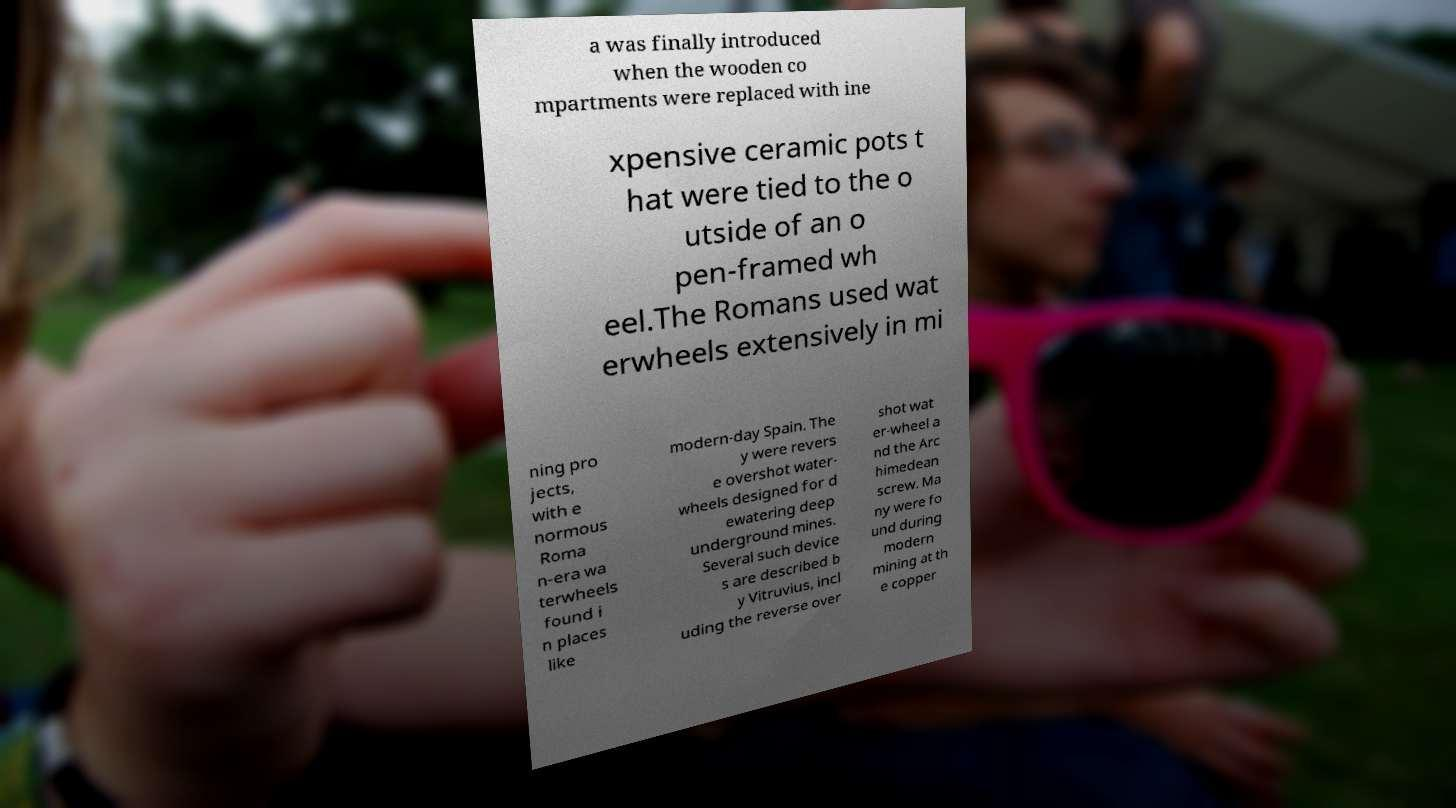What messages or text are displayed in this image? I need them in a readable, typed format. a was finally introduced when the wooden co mpartments were replaced with ine xpensive ceramic pots t hat were tied to the o utside of an o pen-framed wh eel.The Romans used wat erwheels extensively in mi ning pro jects, with e normous Roma n-era wa terwheels found i n places like modern-day Spain. The y were revers e overshot water- wheels designed for d ewatering deep underground mines. Several such device s are described b y Vitruvius, incl uding the reverse over shot wat er-wheel a nd the Arc himedean screw. Ma ny were fo und during modern mining at th e copper 